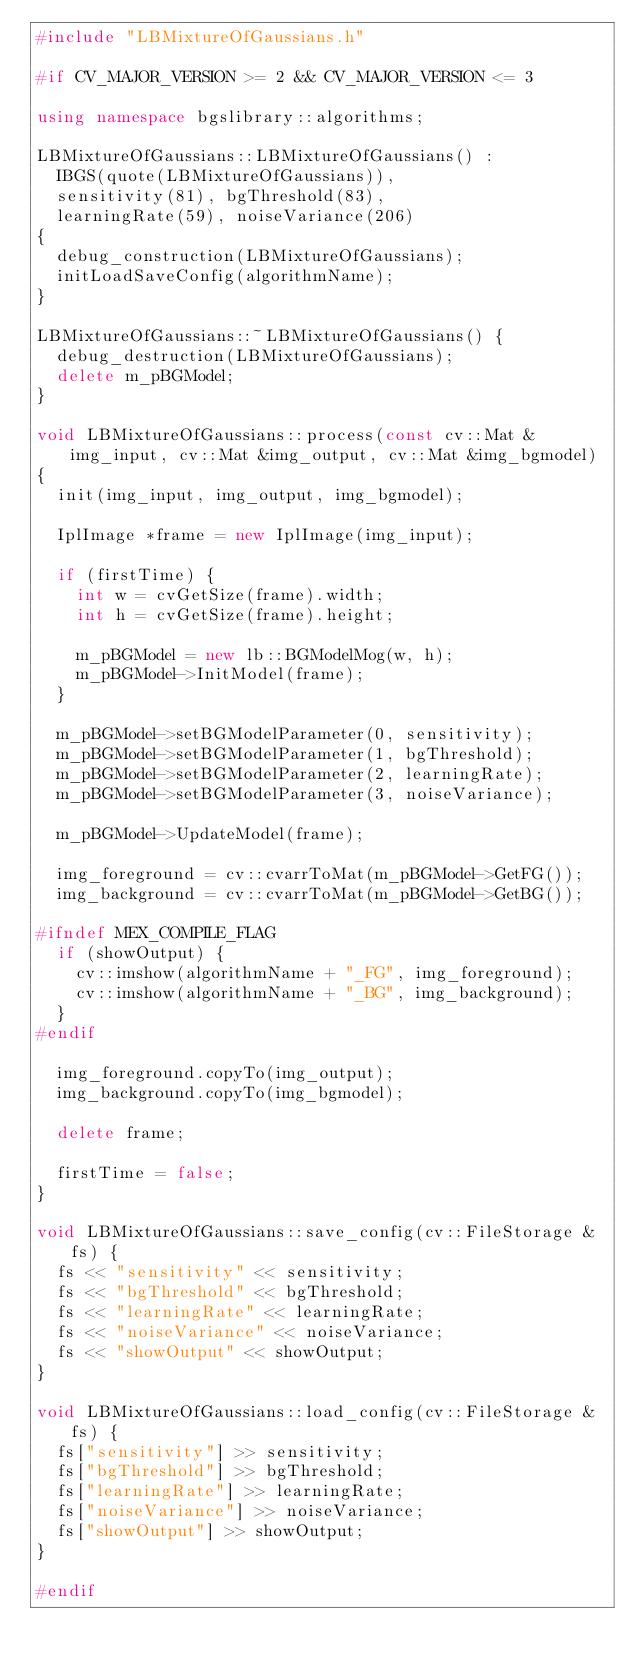<code> <loc_0><loc_0><loc_500><loc_500><_C++_>#include "LBMixtureOfGaussians.h"

#if CV_MAJOR_VERSION >= 2 && CV_MAJOR_VERSION <= 3

using namespace bgslibrary::algorithms;

LBMixtureOfGaussians::LBMixtureOfGaussians() :
  IBGS(quote(LBMixtureOfGaussians)),
  sensitivity(81), bgThreshold(83), 
  learningRate(59), noiseVariance(206)
{
  debug_construction(LBMixtureOfGaussians);
  initLoadSaveConfig(algorithmName);
}

LBMixtureOfGaussians::~LBMixtureOfGaussians() {
  debug_destruction(LBMixtureOfGaussians);
  delete m_pBGModel;
}

void LBMixtureOfGaussians::process(const cv::Mat &img_input, cv::Mat &img_output, cv::Mat &img_bgmodel)
{
  init(img_input, img_output, img_bgmodel);

  IplImage *frame = new IplImage(img_input);

  if (firstTime) {
    int w = cvGetSize(frame).width;
    int h = cvGetSize(frame).height;

    m_pBGModel = new lb::BGModelMog(w, h);
    m_pBGModel->InitModel(frame);
  }

  m_pBGModel->setBGModelParameter(0, sensitivity);
  m_pBGModel->setBGModelParameter(1, bgThreshold);
  m_pBGModel->setBGModelParameter(2, learningRate);
  m_pBGModel->setBGModelParameter(3, noiseVariance);

  m_pBGModel->UpdateModel(frame);

  img_foreground = cv::cvarrToMat(m_pBGModel->GetFG());
  img_background = cv::cvarrToMat(m_pBGModel->GetBG());

#ifndef MEX_COMPILE_FLAG
  if (showOutput) {
    cv::imshow(algorithmName + "_FG", img_foreground);
    cv::imshow(algorithmName + "_BG", img_background);
  }
#endif

  img_foreground.copyTo(img_output);
  img_background.copyTo(img_bgmodel);

  delete frame;

  firstTime = false;
}

void LBMixtureOfGaussians::save_config(cv::FileStorage &fs) {
  fs << "sensitivity" << sensitivity;
  fs << "bgThreshold" << bgThreshold;
  fs << "learningRate" << learningRate;
  fs << "noiseVariance" << noiseVariance;
  fs << "showOutput" << showOutput;
}

void LBMixtureOfGaussians::load_config(cv::FileStorage &fs) {
  fs["sensitivity"] >> sensitivity;
  fs["bgThreshold"] >> bgThreshold;
  fs["learningRate"] >> learningRate;
  fs["noiseVariance"] >> noiseVariance;
  fs["showOutput"] >> showOutput;
}

#endif
</code> 